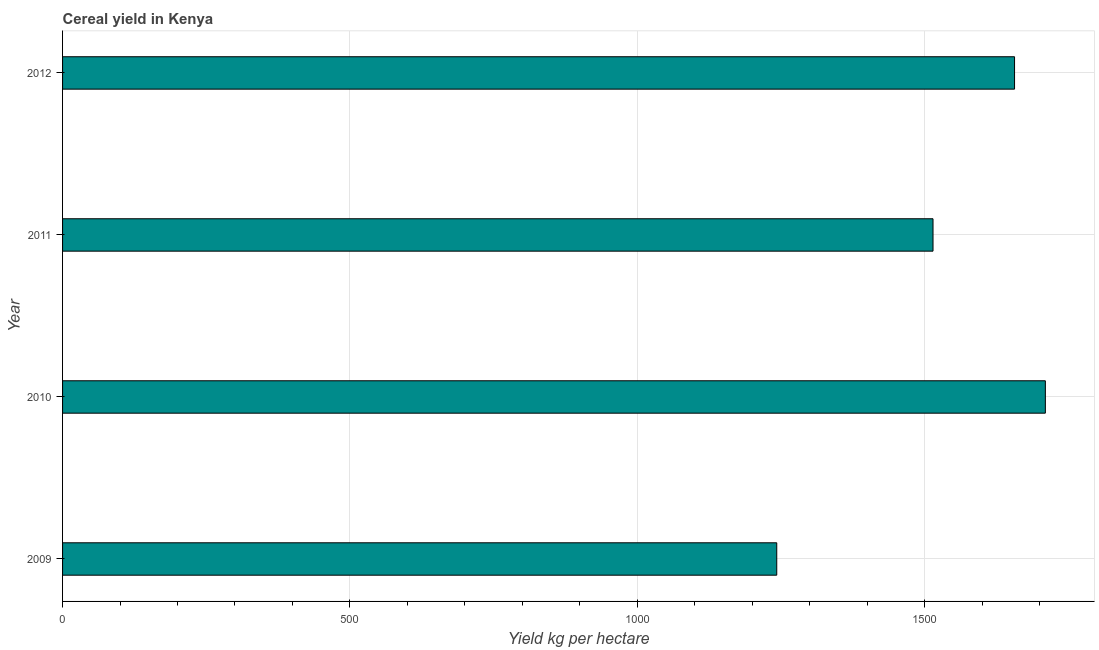Does the graph contain any zero values?
Provide a short and direct response. No. What is the title of the graph?
Make the answer very short. Cereal yield in Kenya. What is the label or title of the X-axis?
Offer a very short reply. Yield kg per hectare. What is the cereal yield in 2011?
Your answer should be compact. 1514.65. Across all years, what is the maximum cereal yield?
Give a very brief answer. 1710.11. Across all years, what is the minimum cereal yield?
Ensure brevity in your answer.  1242.73. In which year was the cereal yield maximum?
Offer a very short reply. 2010. What is the sum of the cereal yield?
Provide a short and direct response. 6123.98. What is the difference between the cereal yield in 2009 and 2012?
Give a very brief answer. -413.77. What is the average cereal yield per year?
Provide a succinct answer. 1530.99. What is the median cereal yield?
Your response must be concise. 1585.57. Do a majority of the years between 2009 and 2011 (inclusive) have cereal yield greater than 1500 kg per hectare?
Offer a very short reply. Yes. What is the ratio of the cereal yield in 2009 to that in 2010?
Ensure brevity in your answer.  0.73. What is the difference between the highest and the second highest cereal yield?
Your response must be concise. 53.61. What is the difference between the highest and the lowest cereal yield?
Offer a terse response. 467.38. How many bars are there?
Provide a short and direct response. 4. Are the values on the major ticks of X-axis written in scientific E-notation?
Your answer should be very brief. No. What is the Yield kg per hectare in 2009?
Make the answer very short. 1242.73. What is the Yield kg per hectare of 2010?
Your response must be concise. 1710.11. What is the Yield kg per hectare in 2011?
Give a very brief answer. 1514.65. What is the Yield kg per hectare of 2012?
Offer a terse response. 1656.5. What is the difference between the Yield kg per hectare in 2009 and 2010?
Offer a terse response. -467.38. What is the difference between the Yield kg per hectare in 2009 and 2011?
Give a very brief answer. -271.92. What is the difference between the Yield kg per hectare in 2009 and 2012?
Your answer should be compact. -413.77. What is the difference between the Yield kg per hectare in 2010 and 2011?
Your answer should be very brief. 195.46. What is the difference between the Yield kg per hectare in 2010 and 2012?
Give a very brief answer. 53.61. What is the difference between the Yield kg per hectare in 2011 and 2012?
Provide a succinct answer. -141.85. What is the ratio of the Yield kg per hectare in 2009 to that in 2010?
Ensure brevity in your answer.  0.73. What is the ratio of the Yield kg per hectare in 2009 to that in 2011?
Provide a short and direct response. 0.82. What is the ratio of the Yield kg per hectare in 2009 to that in 2012?
Offer a terse response. 0.75. What is the ratio of the Yield kg per hectare in 2010 to that in 2011?
Your response must be concise. 1.13. What is the ratio of the Yield kg per hectare in 2010 to that in 2012?
Provide a succinct answer. 1.03. What is the ratio of the Yield kg per hectare in 2011 to that in 2012?
Your response must be concise. 0.91. 